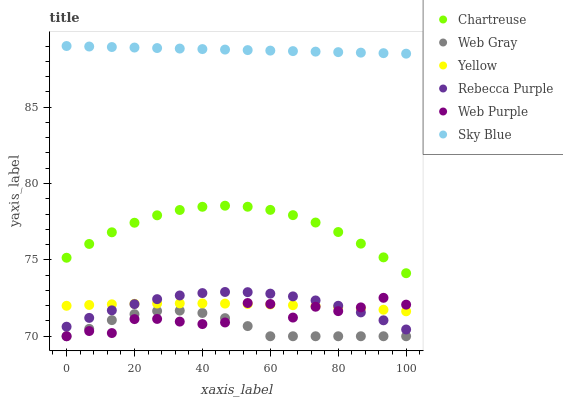Does Web Gray have the minimum area under the curve?
Answer yes or no. Yes. Does Sky Blue have the maximum area under the curve?
Answer yes or no. Yes. Does Chartreuse have the minimum area under the curve?
Answer yes or no. No. Does Chartreuse have the maximum area under the curve?
Answer yes or no. No. Is Sky Blue the smoothest?
Answer yes or no. Yes. Is Web Purple the roughest?
Answer yes or no. Yes. Is Chartreuse the smoothest?
Answer yes or no. No. Is Chartreuse the roughest?
Answer yes or no. No. Does Web Gray have the lowest value?
Answer yes or no. Yes. Does Chartreuse have the lowest value?
Answer yes or no. No. Does Sky Blue have the highest value?
Answer yes or no. Yes. Does Chartreuse have the highest value?
Answer yes or no. No. Is Chartreuse less than Sky Blue?
Answer yes or no. Yes. Is Rebecca Purple greater than Web Gray?
Answer yes or no. Yes. Does Web Purple intersect Web Gray?
Answer yes or no. Yes. Is Web Purple less than Web Gray?
Answer yes or no. No. Is Web Purple greater than Web Gray?
Answer yes or no. No. Does Chartreuse intersect Sky Blue?
Answer yes or no. No. 